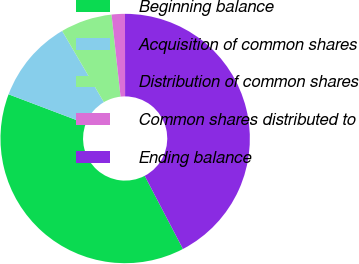<chart> <loc_0><loc_0><loc_500><loc_500><pie_chart><fcel>Beginning balance<fcel>Acquisition of common shares<fcel>Distribution of common shares<fcel>Common shares distributed to<fcel>Ending balance<nl><fcel>38.44%<fcel>10.8%<fcel>6.69%<fcel>1.72%<fcel>42.35%<nl></chart> 